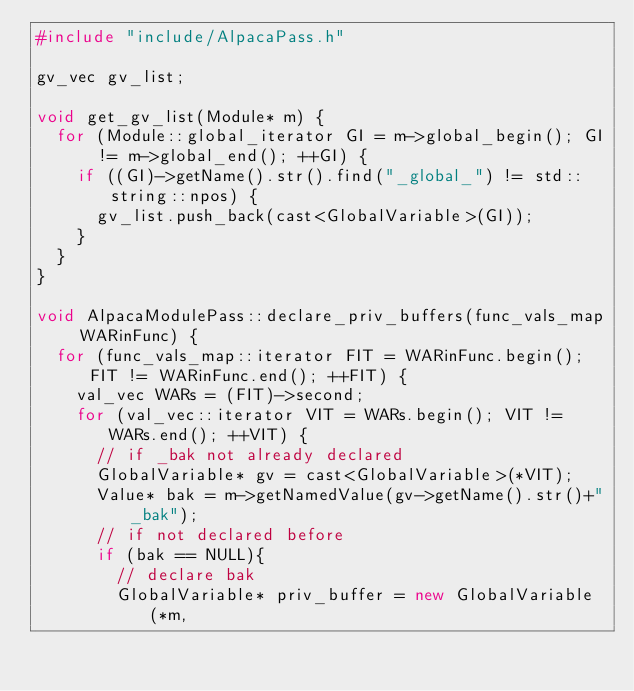Convert code to text. <code><loc_0><loc_0><loc_500><loc_500><_C++_>#include "include/AlpacaPass.h"

gv_vec gv_list;

void get_gv_list(Module* m) {
	for (Module::global_iterator GI = m->global_begin(); GI != m->global_end(); ++GI) {
		if ((GI)->getName().str().find("_global_") != std::string::npos) {
			gv_list.push_back(cast<GlobalVariable>(GI));
		}
	}
}

void AlpacaModulePass::declare_priv_buffers(func_vals_map WARinFunc) {
	for (func_vals_map::iterator FIT = WARinFunc.begin(); FIT != WARinFunc.end(); ++FIT) {
		val_vec WARs = (FIT)->second;
		for (val_vec::iterator VIT = WARs.begin(); VIT != WARs.end(); ++VIT) {
			// if _bak not already declared
			GlobalVariable* gv = cast<GlobalVariable>(*VIT);
			Value* bak = m->getNamedValue(gv->getName().str()+"_bak");
			// if not declared before
			if (bak == NULL){
				// declare bak
				GlobalVariable* priv_buffer = new GlobalVariable(*m, </code> 